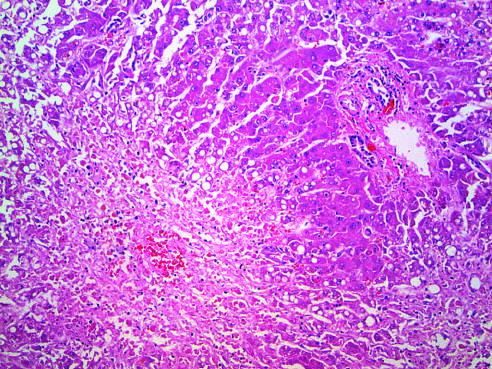where is confluent necrosis seen?
Answer the question using a single word or phrase. In he perivenular region 